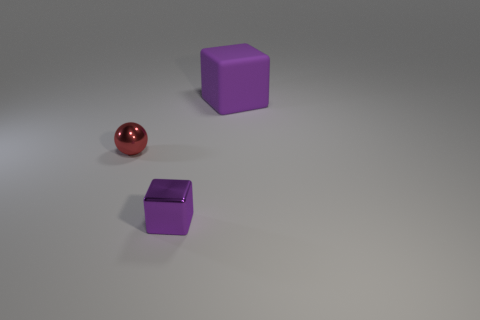Add 3 tiny red metal objects. How many objects exist? 6 Subtract all balls. How many objects are left? 2 Add 3 tiny purple objects. How many tiny purple objects are left? 4 Add 3 spheres. How many spheres exist? 4 Subtract 0 cyan spheres. How many objects are left? 3 Subtract all small green metallic objects. Subtract all small purple shiny cubes. How many objects are left? 2 